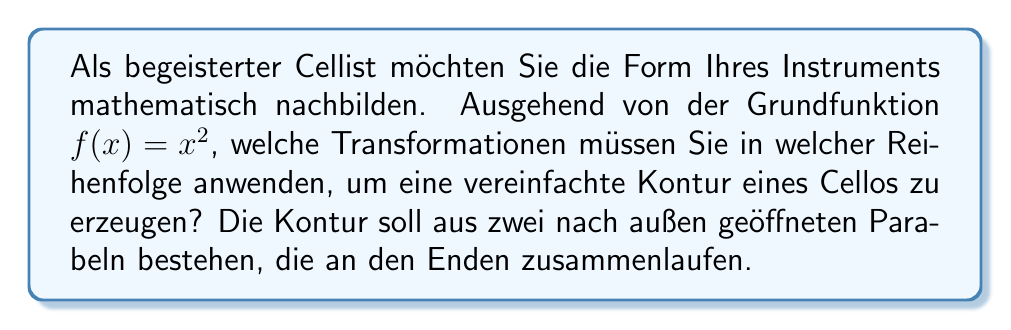Solve this math problem. Um die Form eines Cellos nachzubilden, müssen wir mehrere Transformationen auf die Grundfunktion $f(x)=x^2$ anwenden:

1. Vertikale Streckung: Zunächst strecken wir die Parabel vertikal um den Faktor 2, um sie schmaler zu machen:
   $g(x) = 2x^2$

2. Horizontale Spiegelung: Wir spiegeln die Funktion an der y-Achse, um sie nach links zu öffnen:
   $h(x) = 2(-x)^2 = 2x^2$

3. Vertikale Verschiebung: Wir verschieben die Parabel um 4 Einheiten nach oben:
   $i(x) = 2x^2 + 4$

4. Horizontale Verschiebung: Wir verschieben die Parabel um 2 Einheiten nach rechts:
   $j(x) = 2(x-2)^2 + 4$

5. Vertikale Spiegelung: Wir spiegeln die gesamte Funktion an der x-Achse:
   $k(x) = -(2(x-2)^2 + 4)$

6. Vertikale Verschiebung: Schließlich verschieben wir die Funktion um 8 Einheiten nach oben:
   $l(x) = -(2(x-2)^2 + 4) + 8 = -2(x-2)^2 + 4$

Diese Funktion bildet die linke Hälfte des Cellos. Für die rechte Hälfte wiederholen wir die Schritte 1-4, aber ohne die horizontale Spiegelung:

$r(x) = 2(x+2)^2 + 4$

Die vollständige Cello-Kontur wird durch die Kombination beider Funktionen dargestellt:
$$
C(x) = \begin{cases} 
-2(x-2)^2 + 4, & \text{für } x \leq 2 \\
2(x+2)^2 + 4, & \text{für } x > 2
\end{cases}
$$
Answer: 1. Vertikale Streckung (×2)
2. Horizontale Spiegelung (links)
3. Vertikale Verschiebung (+4)
4. Horizontale Verschiebung (+2)
5. Vertikale Spiegelung
6. Vertikale Verschiebung (+8)
7. Wiederholung der Schritte 1-4 für die rechte Seite ohne horizontale Spiegelung 